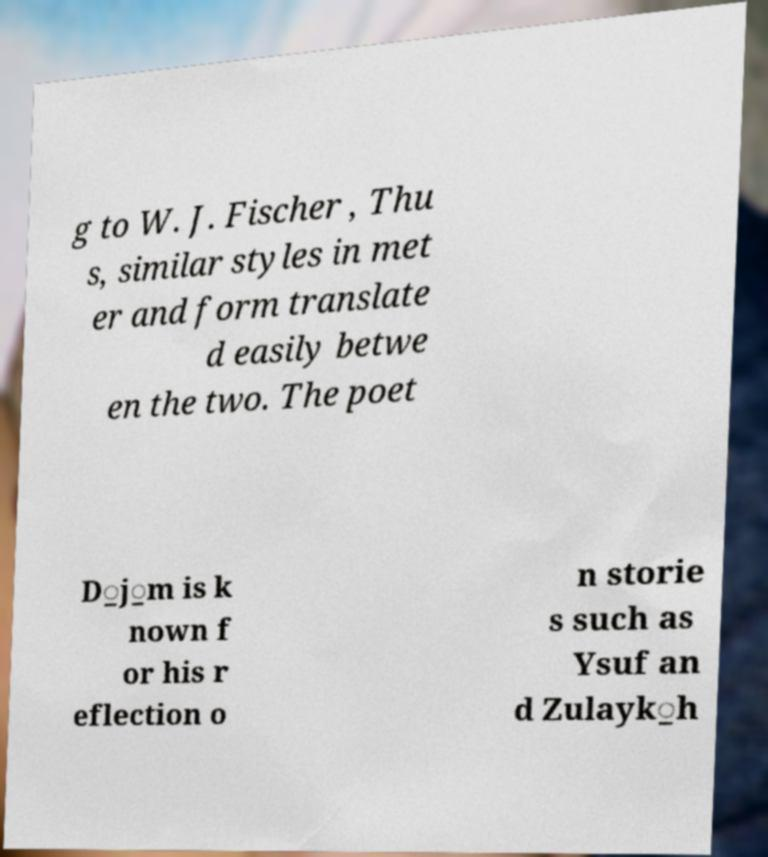Could you extract and type out the text from this image? g to W. J. Fischer , Thu s, similar styles in met er and form translate d easily betwe en the two. The poet D̲j̲m is k nown f or his r eflection o n storie s such as Ysuf an d Zulayk̲h 